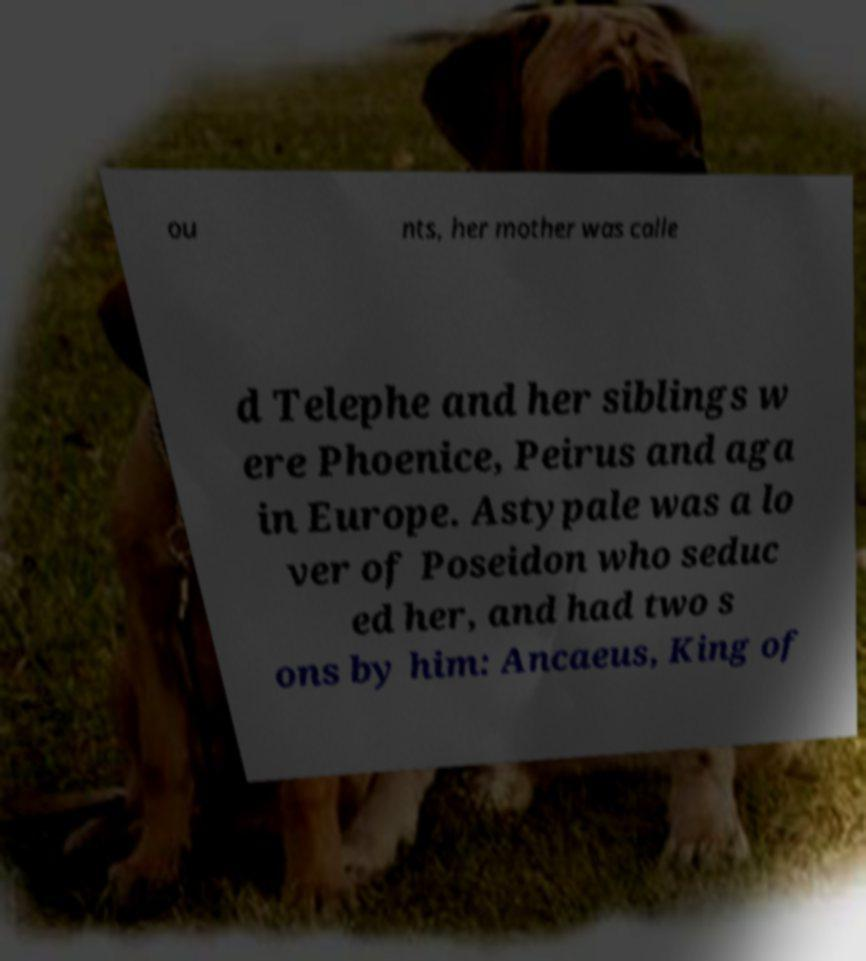There's text embedded in this image that I need extracted. Can you transcribe it verbatim? ou nts, her mother was calle d Telephe and her siblings w ere Phoenice, Peirus and aga in Europe. Astypale was a lo ver of Poseidon who seduc ed her, and had two s ons by him: Ancaeus, King of 